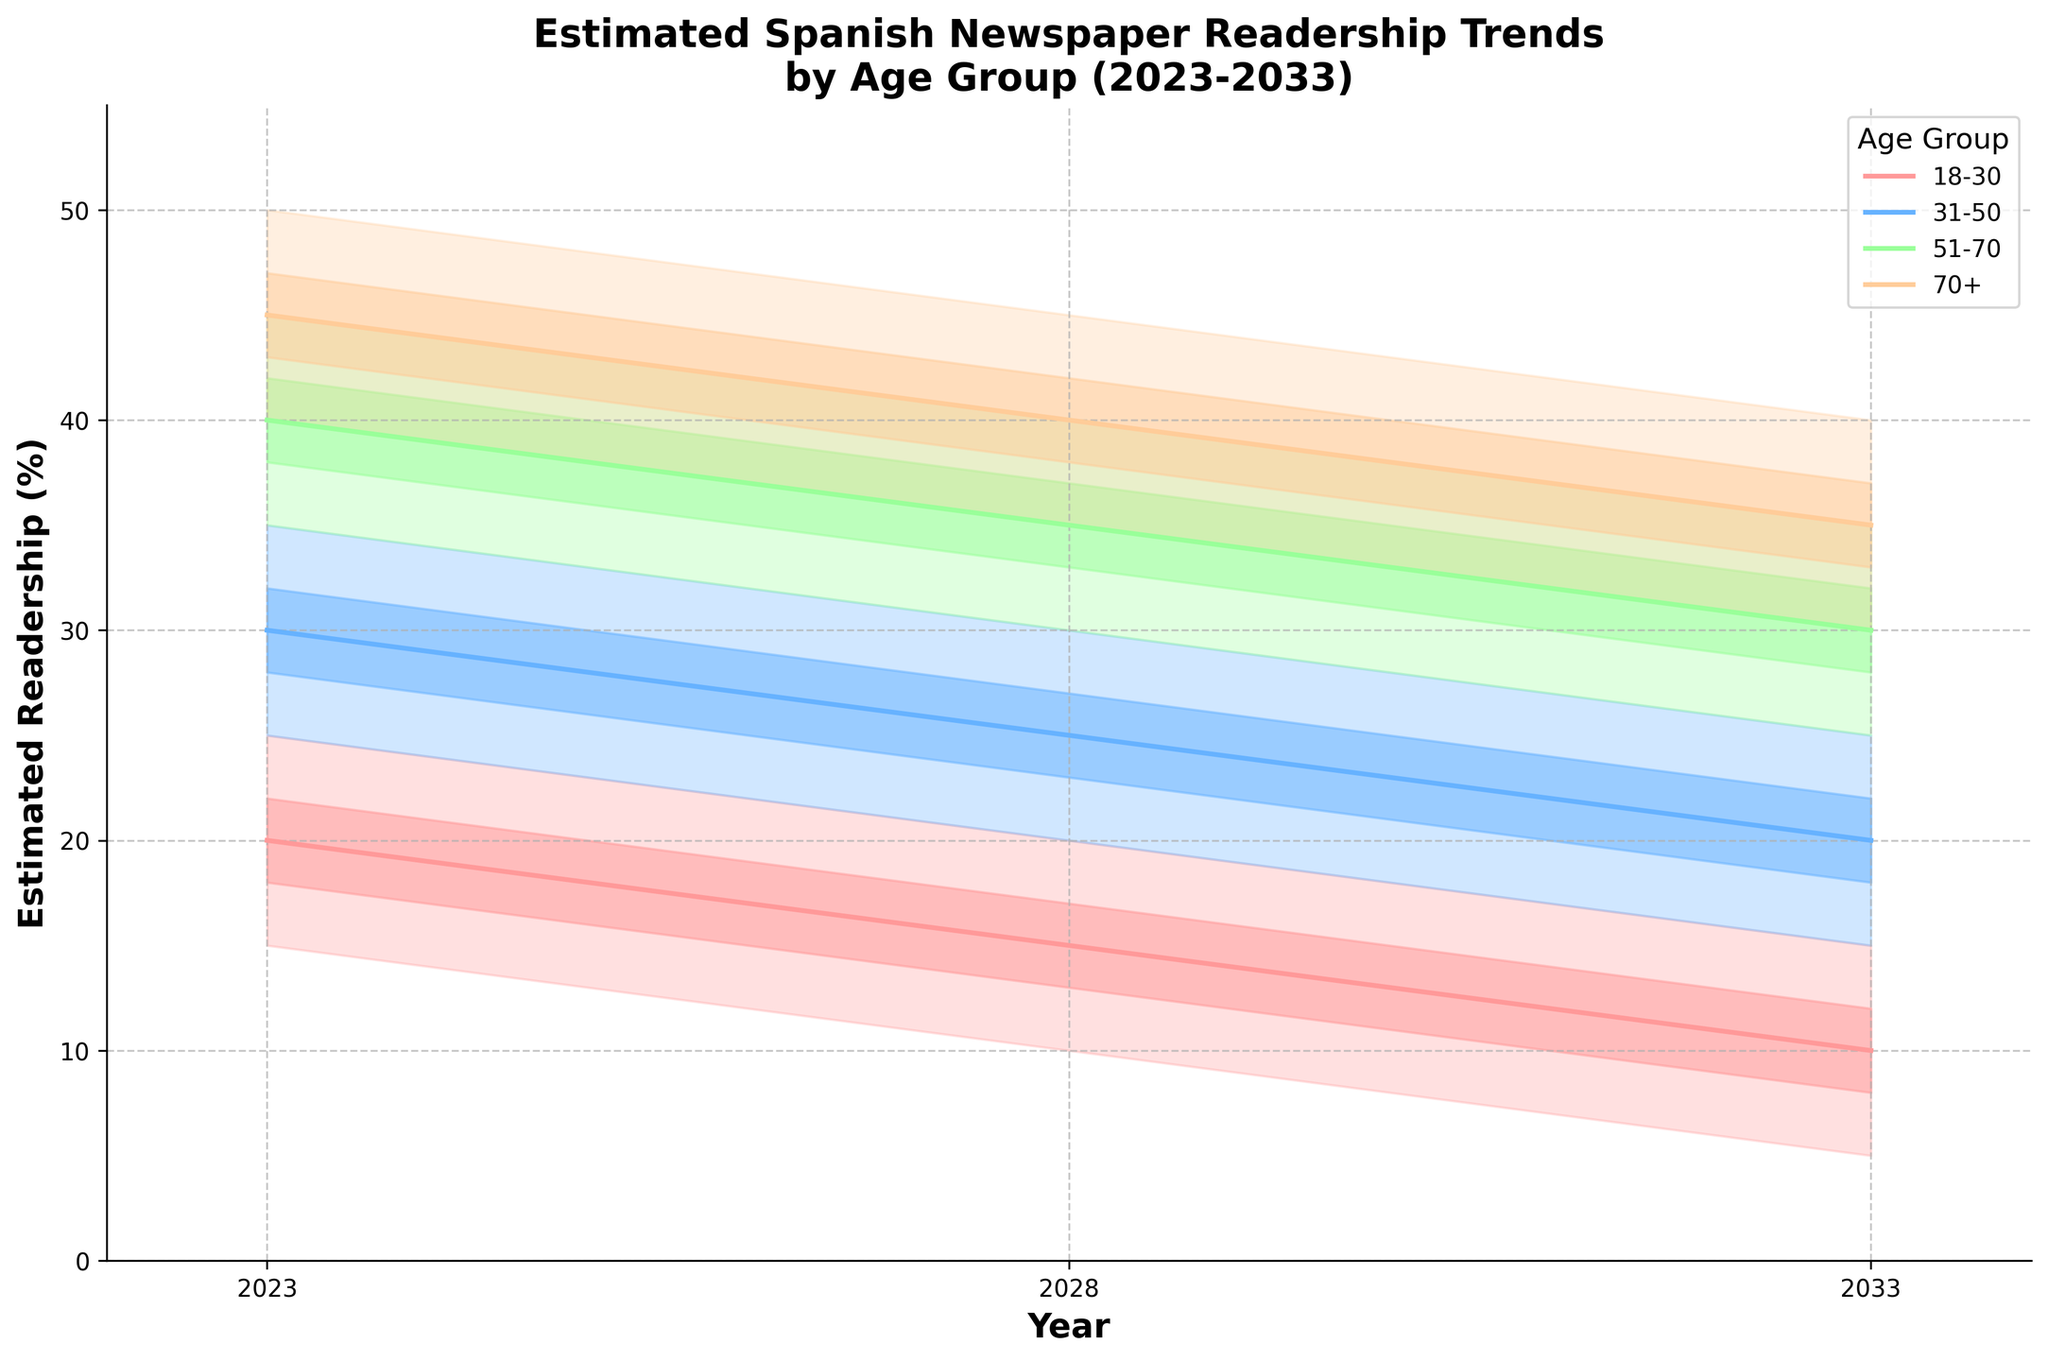What's the title of the chart? The title is usually placed at the top of the chart and summarizes the main content being displayed. In this case, it reads 'Estimated Spanish Newspaper Readership Trends by Age Group (2023-2033)'.
Answer: Estimated Spanish Newspaper Readership Trends by Age Group (2023-2033) What does the Y-axis represent? The Y-axis, usually labeled on the left side of the chart, represents the variable being measured. In this case, it is labeled 'Estimated Readership (%)'.
Answer: Estimated Readership (%) Which age group has the highest base readership in 2023? The base readership for each age group in 2023 can be found by following the base lines. The age group 70+ has the highest base readership at 45%.
Answer: 70+ How does the base readership of the 18-30 age group change from 2023 to 2033? By comparing the base line (middle line) for the 18-30 age group from 2023 to 2033, we can see a decline from 20% in 2023, to 15% in 2028, and finally to 10% in 2033.
Answer: Declines from 20% to 10% Which age group shows the greatest decrease in base readership from 2023 to 2033? To find this, compare the base values for all age groups over the years. The 18-30 age group decreases from 20% in 2023 to 10% in 2033, a 10% drop, which is the largest decline among all groups.
Answer: 18-30 In 2028, what is the range of the estimated readership for the 51-70 age group? For the 51-70 age group in 2028, the pessimistic value is 30% and the optimistic value is 40%, giving a range of 10%.
Answer: 30% to 40% Which age group is projected to have the highest pessimistic readership value in 2033? By looking at the pessimistic values along the bottom edge of the shaded areas in 2033, the 70+ group has the highest pessimistic value at 30%.
Answer: 70+ By how many percentage points does the high estimate for the 31-50 age group change from 2023 to 2033? The high estimate for the 31-50 age group is 32% in 2023 and 22% in 2033, so the change is 32% - 22% = 10 percentage points.
Answer: 10 percentage points Which age group's readership shows the least variability (smallest difference between pessimistic and optimistic values) in 2028? Check the difference between pessimistic and optimistic values for each age group in 2028. The 18-30 age group has values ranging from 10% to 20%, a difference of 10%, which is the smallest.
Answer: 18-30 